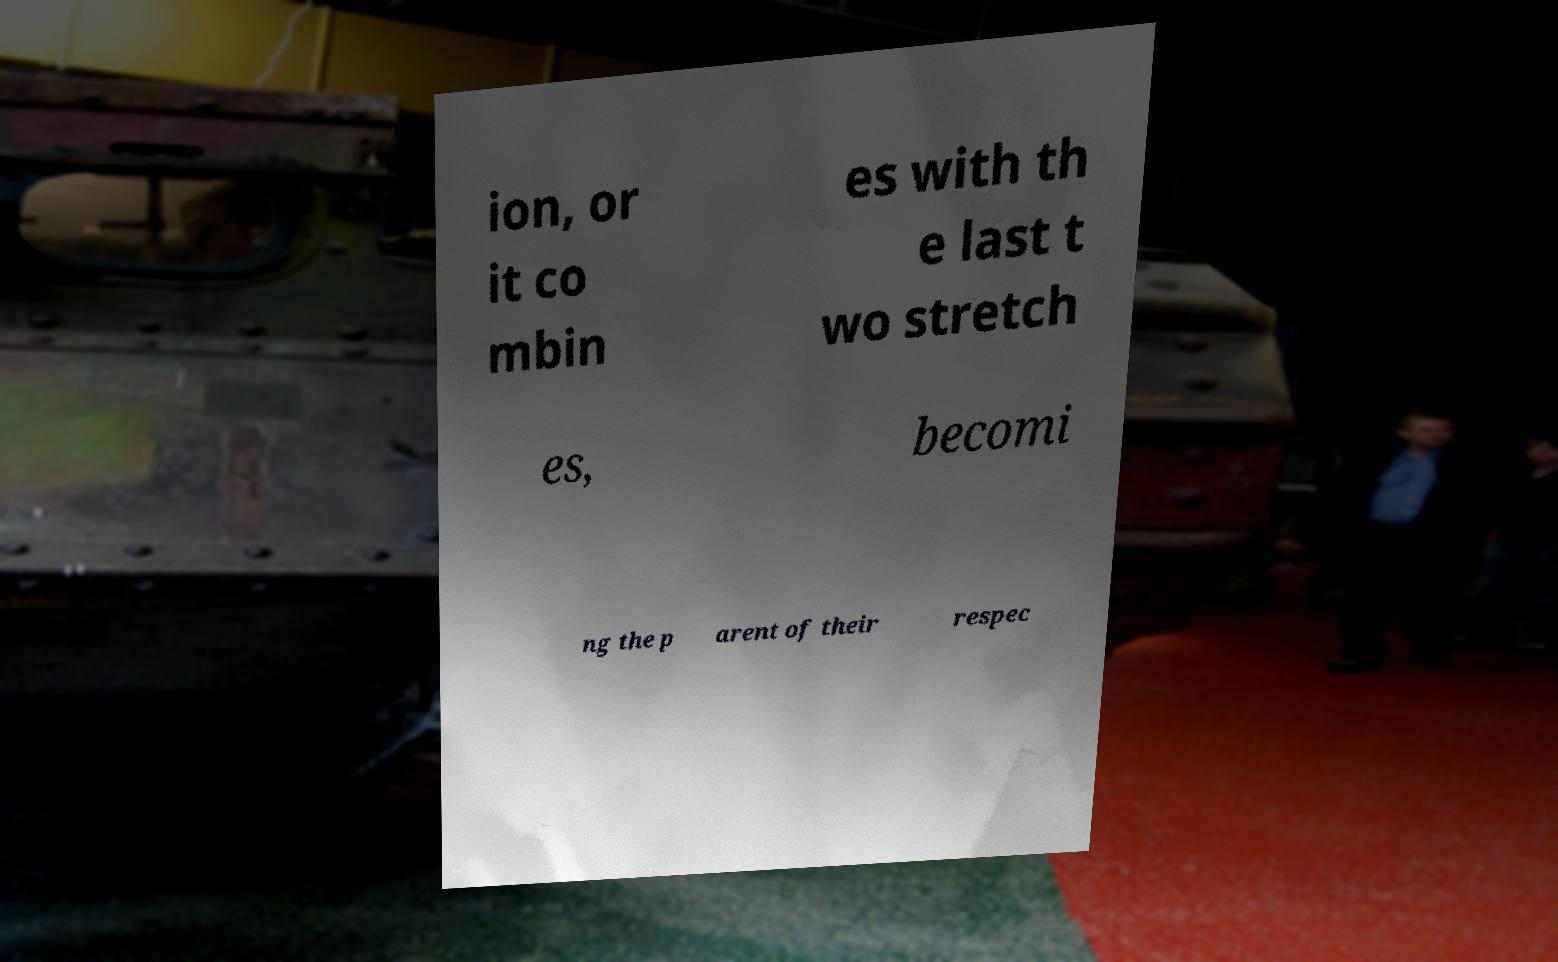Please read and relay the text visible in this image. What does it say? ion, or it co mbin es with th e last t wo stretch es, becomi ng the p arent of their respec 